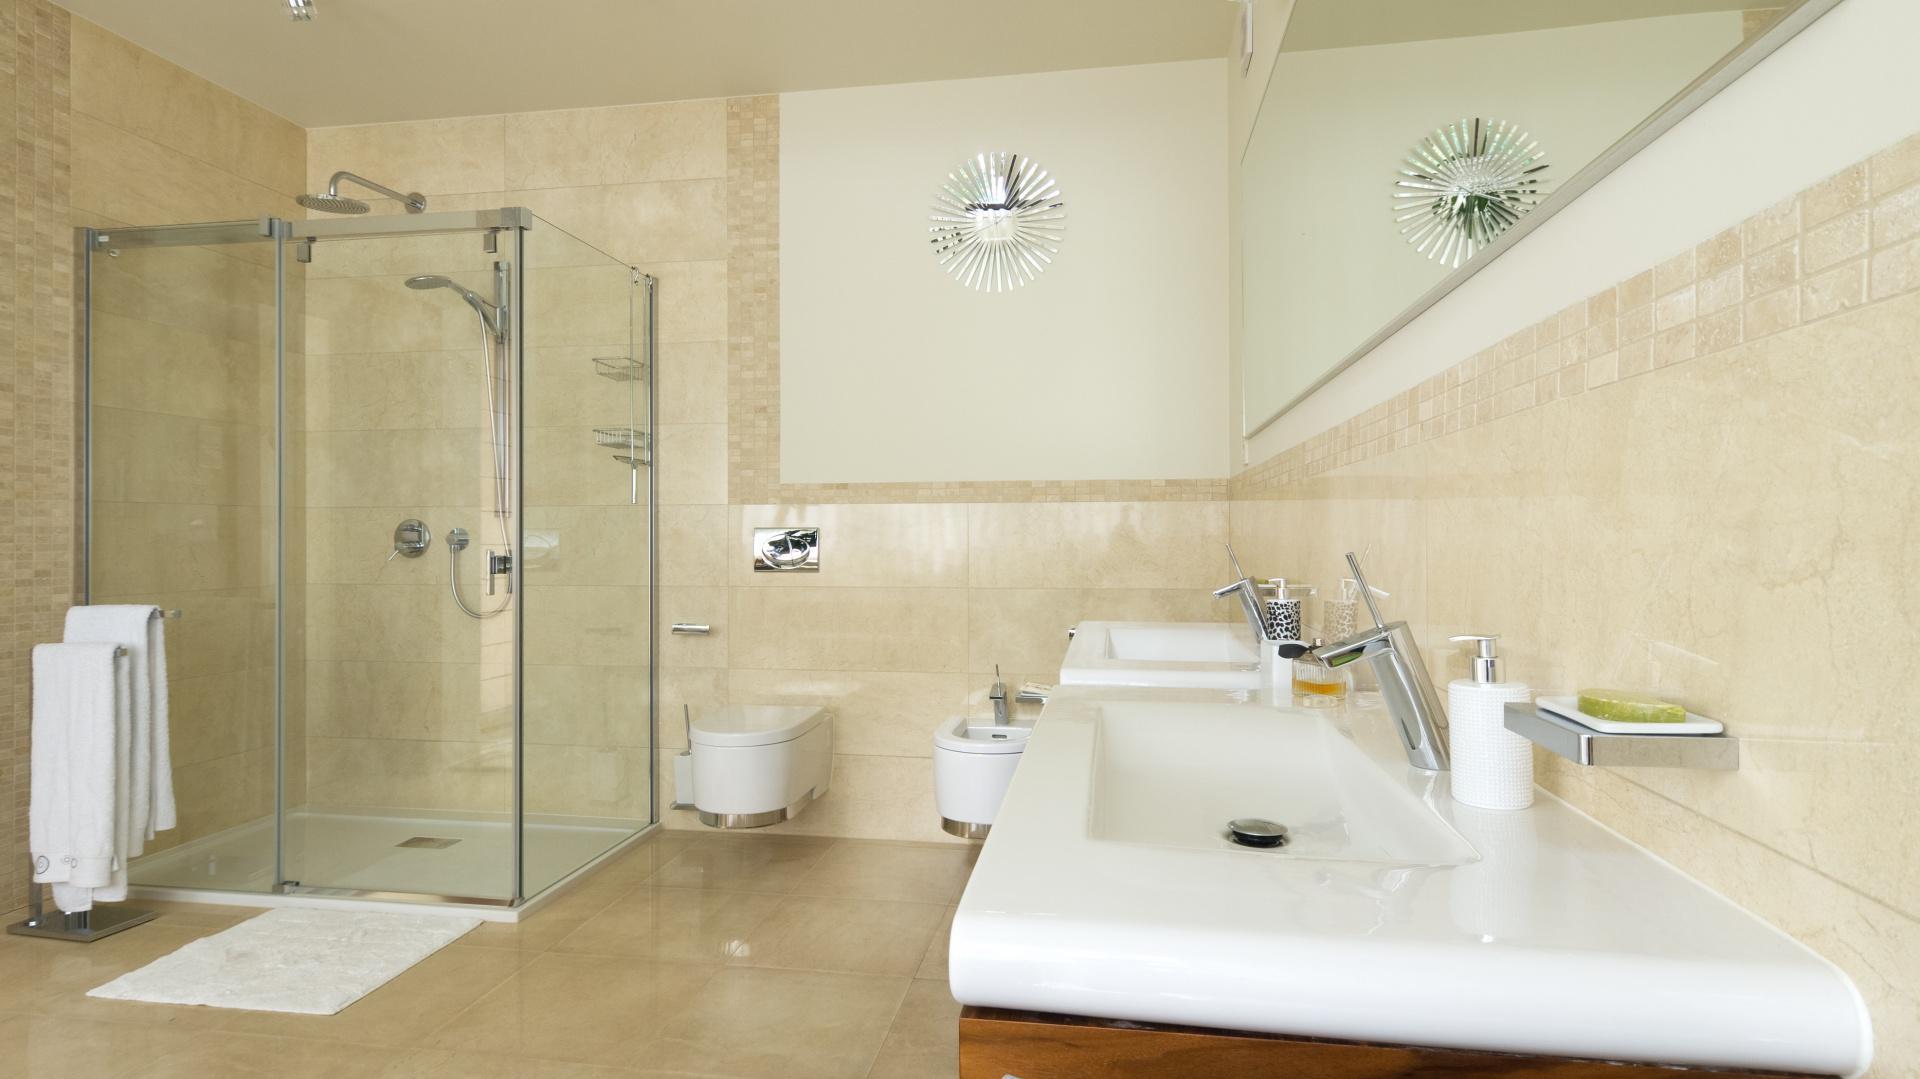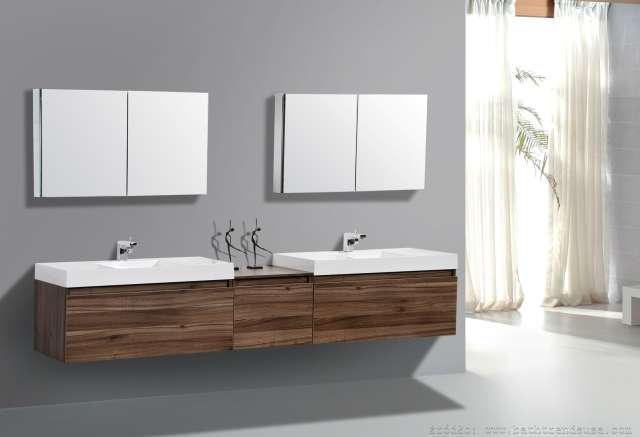The first image is the image on the left, the second image is the image on the right. Assess this claim about the two images: "One bathroom has a long wall-mounted black vanity with separate white sinks, and the other bathroom has a round bathtub and double square sinks.". Correct or not? Answer yes or no. No. The first image is the image on the left, the second image is the image on the right. Given the left and right images, does the statement "One of the sinks is mostly wood paneled." hold true? Answer yes or no. Yes. 